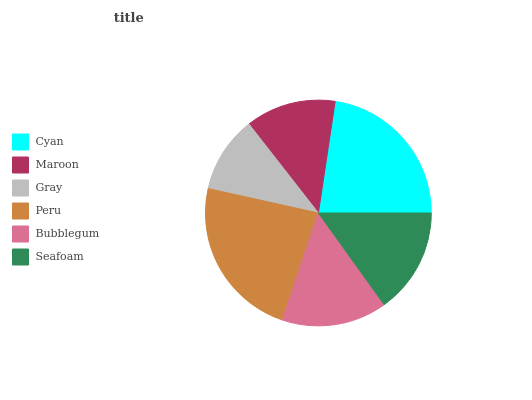Is Gray the minimum?
Answer yes or no. Yes. Is Peru the maximum?
Answer yes or no. Yes. Is Maroon the minimum?
Answer yes or no. No. Is Maroon the maximum?
Answer yes or no. No. Is Cyan greater than Maroon?
Answer yes or no. Yes. Is Maroon less than Cyan?
Answer yes or no. Yes. Is Maroon greater than Cyan?
Answer yes or no. No. Is Cyan less than Maroon?
Answer yes or no. No. Is Seafoam the high median?
Answer yes or no. Yes. Is Bubblegum the low median?
Answer yes or no. Yes. Is Bubblegum the high median?
Answer yes or no. No. Is Peru the low median?
Answer yes or no. No. 